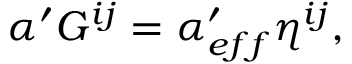Convert formula to latex. <formula><loc_0><loc_0><loc_500><loc_500>\alpha ^ { \prime } G ^ { i j } = \alpha _ { e f f } ^ { \prime } \eta ^ { i j } ,</formula> 